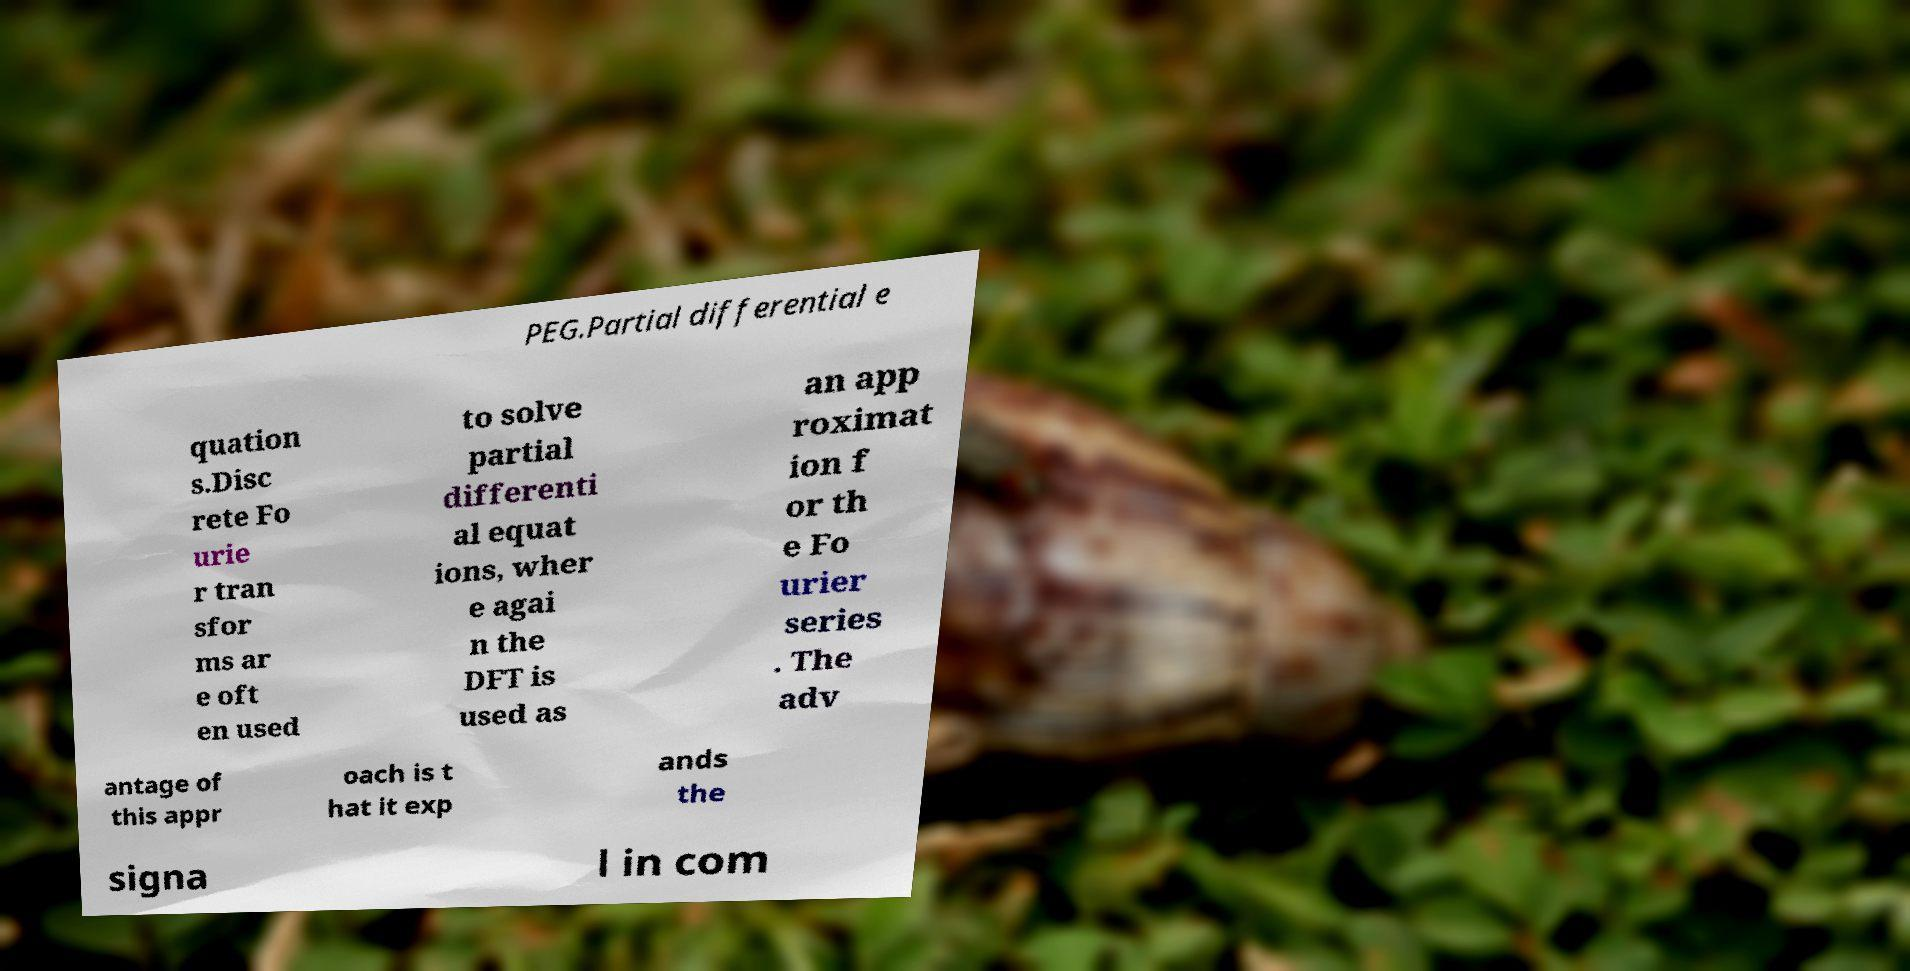For documentation purposes, I need the text within this image transcribed. Could you provide that? PEG.Partial differential e quation s.Disc rete Fo urie r tran sfor ms ar e oft en used to solve partial differenti al equat ions, wher e agai n the DFT is used as an app roximat ion f or th e Fo urier series . The adv antage of this appr oach is t hat it exp ands the signa l in com 